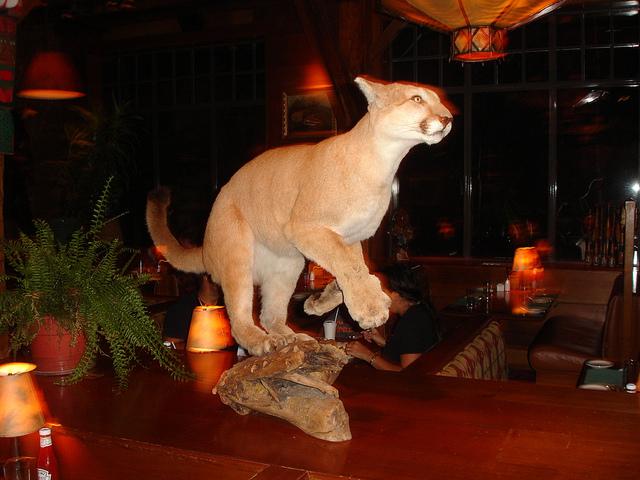Is the cat pouncing?
Short answer required. Yes. What is this cat doing on the table?
Keep it brief. Standing. What kind of cat is pictured?
Be succinct. Bobcat. 